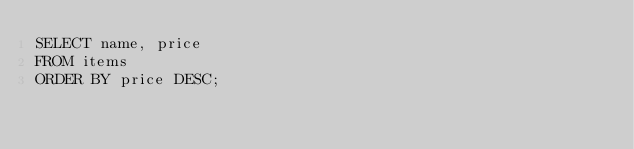<code> <loc_0><loc_0><loc_500><loc_500><_SQL_>SELECT name, price
FROM items
ORDER BY price DESC;
</code> 